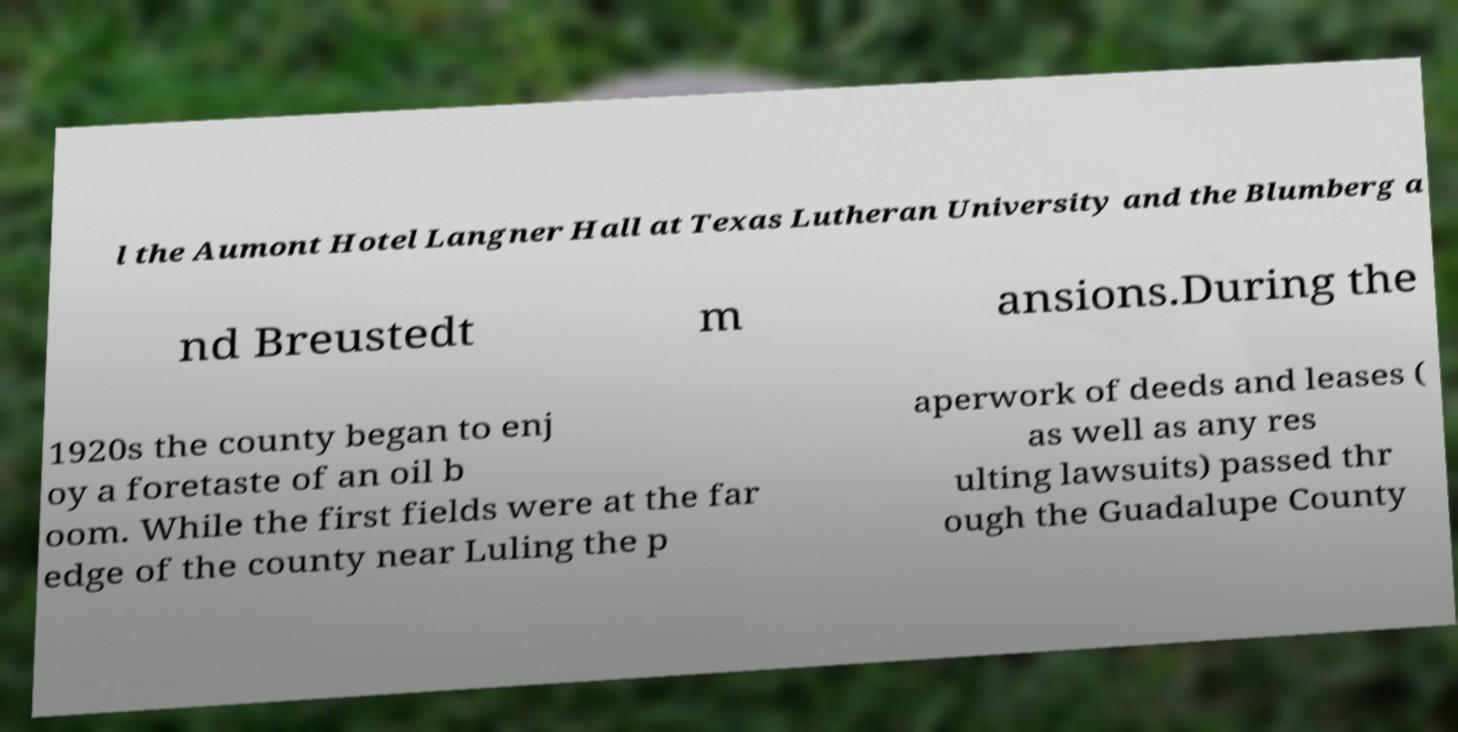Can you accurately transcribe the text from the provided image for me? l the Aumont Hotel Langner Hall at Texas Lutheran University and the Blumberg a nd Breustedt m ansions.During the 1920s the county began to enj oy a foretaste of an oil b oom. While the first fields were at the far edge of the county near Luling the p aperwork of deeds and leases ( as well as any res ulting lawsuits) passed thr ough the Guadalupe County 